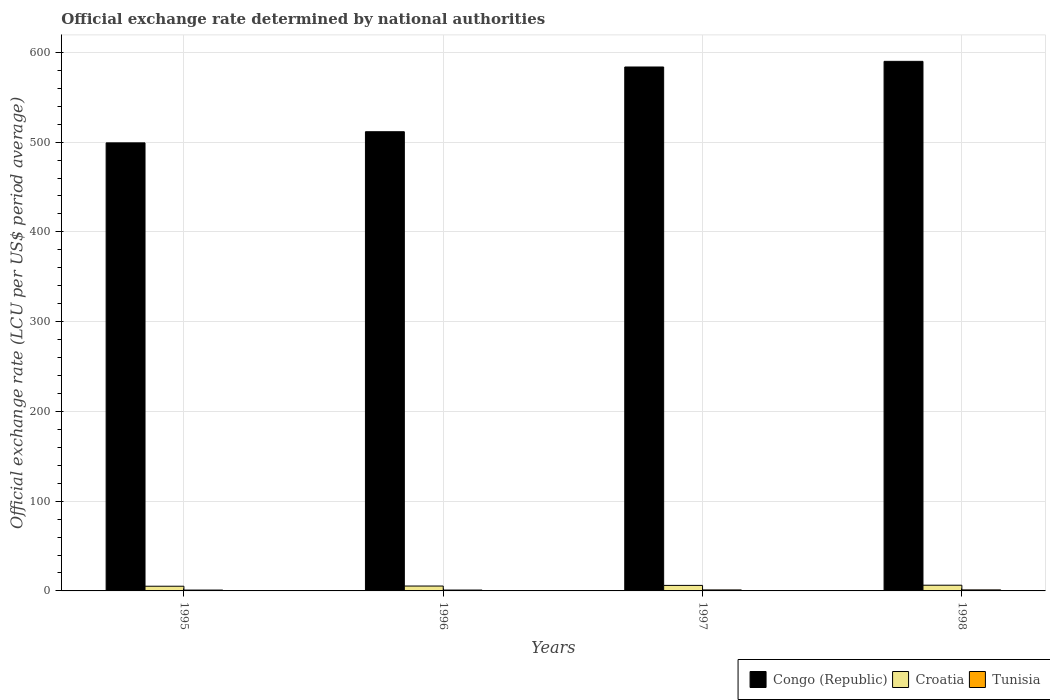How many groups of bars are there?
Provide a succinct answer. 4. Are the number of bars on each tick of the X-axis equal?
Offer a very short reply. Yes. How many bars are there on the 2nd tick from the left?
Make the answer very short. 3. What is the label of the 2nd group of bars from the left?
Provide a short and direct response. 1996. What is the official exchange rate in Croatia in 1997?
Give a very brief answer. 6.16. Across all years, what is the maximum official exchange rate in Croatia?
Give a very brief answer. 6.36. Across all years, what is the minimum official exchange rate in Tunisia?
Offer a very short reply. 0.95. In which year was the official exchange rate in Croatia maximum?
Your answer should be very brief. 1998. In which year was the official exchange rate in Croatia minimum?
Your answer should be very brief. 1995. What is the total official exchange rate in Croatia in the graph?
Give a very brief answer. 23.19. What is the difference between the official exchange rate in Congo (Republic) in 1997 and that in 1998?
Provide a short and direct response. -6.28. What is the difference between the official exchange rate in Croatia in 1998 and the official exchange rate in Tunisia in 1996?
Ensure brevity in your answer.  5.39. What is the average official exchange rate in Congo (Republic) per year?
Provide a short and direct response. 546.08. In the year 1996, what is the difference between the official exchange rate in Croatia and official exchange rate in Tunisia?
Provide a succinct answer. 4.46. In how many years, is the official exchange rate in Croatia greater than 40 LCU?
Keep it short and to the point. 0. What is the ratio of the official exchange rate in Tunisia in 1995 to that in 1996?
Offer a terse response. 0.97. Is the difference between the official exchange rate in Croatia in 1997 and 1998 greater than the difference between the official exchange rate in Tunisia in 1997 and 1998?
Make the answer very short. No. What is the difference between the highest and the second highest official exchange rate in Congo (Republic)?
Offer a terse response. 6.28. What is the difference between the highest and the lowest official exchange rate in Congo (Republic)?
Offer a very short reply. 90.8. What does the 1st bar from the left in 1997 represents?
Keep it short and to the point. Congo (Republic). What does the 1st bar from the right in 1997 represents?
Offer a very short reply. Tunisia. How many bars are there?
Your response must be concise. 12. Are all the bars in the graph horizontal?
Your answer should be very brief. No. What is the difference between two consecutive major ticks on the Y-axis?
Give a very brief answer. 100. Does the graph contain grids?
Ensure brevity in your answer.  Yes. Where does the legend appear in the graph?
Keep it short and to the point. Bottom right. How are the legend labels stacked?
Offer a very short reply. Horizontal. What is the title of the graph?
Your answer should be very brief. Official exchange rate determined by national authorities. What is the label or title of the X-axis?
Give a very brief answer. Years. What is the label or title of the Y-axis?
Keep it short and to the point. Official exchange rate (LCU per US$ period average). What is the Official exchange rate (LCU per US$ period average) of Congo (Republic) in 1995?
Keep it short and to the point. 499.15. What is the Official exchange rate (LCU per US$ period average) of Croatia in 1995?
Offer a very short reply. 5.23. What is the Official exchange rate (LCU per US$ period average) in Tunisia in 1995?
Your answer should be very brief. 0.95. What is the Official exchange rate (LCU per US$ period average) of Congo (Republic) in 1996?
Your response must be concise. 511.55. What is the Official exchange rate (LCU per US$ period average) in Croatia in 1996?
Your answer should be very brief. 5.43. What is the Official exchange rate (LCU per US$ period average) in Tunisia in 1996?
Your answer should be compact. 0.97. What is the Official exchange rate (LCU per US$ period average) of Congo (Republic) in 1997?
Provide a short and direct response. 583.67. What is the Official exchange rate (LCU per US$ period average) of Croatia in 1997?
Provide a short and direct response. 6.16. What is the Official exchange rate (LCU per US$ period average) in Tunisia in 1997?
Ensure brevity in your answer.  1.11. What is the Official exchange rate (LCU per US$ period average) in Congo (Republic) in 1998?
Ensure brevity in your answer.  589.95. What is the Official exchange rate (LCU per US$ period average) in Croatia in 1998?
Give a very brief answer. 6.36. What is the Official exchange rate (LCU per US$ period average) of Tunisia in 1998?
Your response must be concise. 1.14. Across all years, what is the maximum Official exchange rate (LCU per US$ period average) in Congo (Republic)?
Offer a terse response. 589.95. Across all years, what is the maximum Official exchange rate (LCU per US$ period average) of Croatia?
Your answer should be very brief. 6.36. Across all years, what is the maximum Official exchange rate (LCU per US$ period average) of Tunisia?
Make the answer very short. 1.14. Across all years, what is the minimum Official exchange rate (LCU per US$ period average) of Congo (Republic)?
Make the answer very short. 499.15. Across all years, what is the minimum Official exchange rate (LCU per US$ period average) of Croatia?
Provide a succinct answer. 5.23. Across all years, what is the minimum Official exchange rate (LCU per US$ period average) in Tunisia?
Ensure brevity in your answer.  0.95. What is the total Official exchange rate (LCU per US$ period average) in Congo (Republic) in the graph?
Offer a terse response. 2184.32. What is the total Official exchange rate (LCU per US$ period average) in Croatia in the graph?
Give a very brief answer. 23.19. What is the total Official exchange rate (LCU per US$ period average) in Tunisia in the graph?
Your response must be concise. 4.16. What is the difference between the Official exchange rate (LCU per US$ period average) in Congo (Republic) in 1995 and that in 1996?
Your response must be concise. -12.4. What is the difference between the Official exchange rate (LCU per US$ period average) in Croatia in 1995 and that in 1996?
Keep it short and to the point. -0.2. What is the difference between the Official exchange rate (LCU per US$ period average) of Tunisia in 1995 and that in 1996?
Your answer should be very brief. -0.03. What is the difference between the Official exchange rate (LCU per US$ period average) in Congo (Republic) in 1995 and that in 1997?
Your answer should be very brief. -84.52. What is the difference between the Official exchange rate (LCU per US$ period average) in Croatia in 1995 and that in 1997?
Your response must be concise. -0.93. What is the difference between the Official exchange rate (LCU per US$ period average) of Tunisia in 1995 and that in 1997?
Offer a terse response. -0.16. What is the difference between the Official exchange rate (LCU per US$ period average) of Congo (Republic) in 1995 and that in 1998?
Ensure brevity in your answer.  -90.8. What is the difference between the Official exchange rate (LCU per US$ period average) of Croatia in 1995 and that in 1998?
Keep it short and to the point. -1.13. What is the difference between the Official exchange rate (LCU per US$ period average) in Tunisia in 1995 and that in 1998?
Ensure brevity in your answer.  -0.19. What is the difference between the Official exchange rate (LCU per US$ period average) of Congo (Republic) in 1996 and that in 1997?
Offer a very short reply. -72.12. What is the difference between the Official exchange rate (LCU per US$ period average) in Croatia in 1996 and that in 1997?
Provide a succinct answer. -0.73. What is the difference between the Official exchange rate (LCU per US$ period average) of Tunisia in 1996 and that in 1997?
Your answer should be very brief. -0.13. What is the difference between the Official exchange rate (LCU per US$ period average) of Congo (Republic) in 1996 and that in 1998?
Ensure brevity in your answer.  -78.4. What is the difference between the Official exchange rate (LCU per US$ period average) in Croatia in 1996 and that in 1998?
Your answer should be compact. -0.93. What is the difference between the Official exchange rate (LCU per US$ period average) in Tunisia in 1996 and that in 1998?
Offer a very short reply. -0.17. What is the difference between the Official exchange rate (LCU per US$ period average) in Congo (Republic) in 1997 and that in 1998?
Your answer should be compact. -6.28. What is the difference between the Official exchange rate (LCU per US$ period average) of Croatia in 1997 and that in 1998?
Ensure brevity in your answer.  -0.2. What is the difference between the Official exchange rate (LCU per US$ period average) of Tunisia in 1997 and that in 1998?
Offer a terse response. -0.03. What is the difference between the Official exchange rate (LCU per US$ period average) of Congo (Republic) in 1995 and the Official exchange rate (LCU per US$ period average) of Croatia in 1996?
Your answer should be very brief. 493.71. What is the difference between the Official exchange rate (LCU per US$ period average) in Congo (Republic) in 1995 and the Official exchange rate (LCU per US$ period average) in Tunisia in 1996?
Ensure brevity in your answer.  498.18. What is the difference between the Official exchange rate (LCU per US$ period average) in Croatia in 1995 and the Official exchange rate (LCU per US$ period average) in Tunisia in 1996?
Ensure brevity in your answer.  4.26. What is the difference between the Official exchange rate (LCU per US$ period average) in Congo (Republic) in 1995 and the Official exchange rate (LCU per US$ period average) in Croatia in 1997?
Give a very brief answer. 492.99. What is the difference between the Official exchange rate (LCU per US$ period average) of Congo (Republic) in 1995 and the Official exchange rate (LCU per US$ period average) of Tunisia in 1997?
Offer a terse response. 498.04. What is the difference between the Official exchange rate (LCU per US$ period average) in Croatia in 1995 and the Official exchange rate (LCU per US$ period average) in Tunisia in 1997?
Your response must be concise. 4.12. What is the difference between the Official exchange rate (LCU per US$ period average) of Congo (Republic) in 1995 and the Official exchange rate (LCU per US$ period average) of Croatia in 1998?
Your answer should be very brief. 492.79. What is the difference between the Official exchange rate (LCU per US$ period average) in Congo (Republic) in 1995 and the Official exchange rate (LCU per US$ period average) in Tunisia in 1998?
Make the answer very short. 498.01. What is the difference between the Official exchange rate (LCU per US$ period average) of Croatia in 1995 and the Official exchange rate (LCU per US$ period average) of Tunisia in 1998?
Provide a short and direct response. 4.09. What is the difference between the Official exchange rate (LCU per US$ period average) in Congo (Republic) in 1996 and the Official exchange rate (LCU per US$ period average) in Croatia in 1997?
Make the answer very short. 505.39. What is the difference between the Official exchange rate (LCU per US$ period average) of Congo (Republic) in 1996 and the Official exchange rate (LCU per US$ period average) of Tunisia in 1997?
Your answer should be very brief. 510.45. What is the difference between the Official exchange rate (LCU per US$ period average) in Croatia in 1996 and the Official exchange rate (LCU per US$ period average) in Tunisia in 1997?
Your answer should be very brief. 4.33. What is the difference between the Official exchange rate (LCU per US$ period average) of Congo (Republic) in 1996 and the Official exchange rate (LCU per US$ period average) of Croatia in 1998?
Make the answer very short. 505.19. What is the difference between the Official exchange rate (LCU per US$ period average) of Congo (Republic) in 1996 and the Official exchange rate (LCU per US$ period average) of Tunisia in 1998?
Your response must be concise. 510.41. What is the difference between the Official exchange rate (LCU per US$ period average) in Croatia in 1996 and the Official exchange rate (LCU per US$ period average) in Tunisia in 1998?
Ensure brevity in your answer.  4.3. What is the difference between the Official exchange rate (LCU per US$ period average) of Congo (Republic) in 1997 and the Official exchange rate (LCU per US$ period average) of Croatia in 1998?
Offer a very short reply. 577.31. What is the difference between the Official exchange rate (LCU per US$ period average) in Congo (Republic) in 1997 and the Official exchange rate (LCU per US$ period average) in Tunisia in 1998?
Provide a short and direct response. 582.53. What is the difference between the Official exchange rate (LCU per US$ period average) in Croatia in 1997 and the Official exchange rate (LCU per US$ period average) in Tunisia in 1998?
Keep it short and to the point. 5.02. What is the average Official exchange rate (LCU per US$ period average) of Congo (Republic) per year?
Ensure brevity in your answer.  546.08. What is the average Official exchange rate (LCU per US$ period average) of Croatia per year?
Your response must be concise. 5.8. What is the average Official exchange rate (LCU per US$ period average) of Tunisia per year?
Offer a terse response. 1.04. In the year 1995, what is the difference between the Official exchange rate (LCU per US$ period average) in Congo (Republic) and Official exchange rate (LCU per US$ period average) in Croatia?
Offer a terse response. 493.92. In the year 1995, what is the difference between the Official exchange rate (LCU per US$ period average) in Congo (Republic) and Official exchange rate (LCU per US$ period average) in Tunisia?
Ensure brevity in your answer.  498.2. In the year 1995, what is the difference between the Official exchange rate (LCU per US$ period average) of Croatia and Official exchange rate (LCU per US$ period average) of Tunisia?
Give a very brief answer. 4.29. In the year 1996, what is the difference between the Official exchange rate (LCU per US$ period average) in Congo (Republic) and Official exchange rate (LCU per US$ period average) in Croatia?
Provide a succinct answer. 506.12. In the year 1996, what is the difference between the Official exchange rate (LCU per US$ period average) in Congo (Republic) and Official exchange rate (LCU per US$ period average) in Tunisia?
Keep it short and to the point. 510.58. In the year 1996, what is the difference between the Official exchange rate (LCU per US$ period average) in Croatia and Official exchange rate (LCU per US$ period average) in Tunisia?
Provide a short and direct response. 4.46. In the year 1997, what is the difference between the Official exchange rate (LCU per US$ period average) of Congo (Republic) and Official exchange rate (LCU per US$ period average) of Croatia?
Provide a short and direct response. 577.51. In the year 1997, what is the difference between the Official exchange rate (LCU per US$ period average) in Congo (Republic) and Official exchange rate (LCU per US$ period average) in Tunisia?
Give a very brief answer. 582.56. In the year 1997, what is the difference between the Official exchange rate (LCU per US$ period average) in Croatia and Official exchange rate (LCU per US$ period average) in Tunisia?
Keep it short and to the point. 5.05. In the year 1998, what is the difference between the Official exchange rate (LCU per US$ period average) of Congo (Republic) and Official exchange rate (LCU per US$ period average) of Croatia?
Give a very brief answer. 583.59. In the year 1998, what is the difference between the Official exchange rate (LCU per US$ period average) in Congo (Republic) and Official exchange rate (LCU per US$ period average) in Tunisia?
Provide a short and direct response. 588.81. In the year 1998, what is the difference between the Official exchange rate (LCU per US$ period average) of Croatia and Official exchange rate (LCU per US$ period average) of Tunisia?
Your answer should be compact. 5.22. What is the ratio of the Official exchange rate (LCU per US$ period average) of Congo (Republic) in 1995 to that in 1996?
Keep it short and to the point. 0.98. What is the ratio of the Official exchange rate (LCU per US$ period average) of Croatia in 1995 to that in 1996?
Your answer should be very brief. 0.96. What is the ratio of the Official exchange rate (LCU per US$ period average) of Tunisia in 1995 to that in 1996?
Provide a succinct answer. 0.97. What is the ratio of the Official exchange rate (LCU per US$ period average) of Congo (Republic) in 1995 to that in 1997?
Your response must be concise. 0.86. What is the ratio of the Official exchange rate (LCU per US$ period average) in Croatia in 1995 to that in 1997?
Offer a terse response. 0.85. What is the ratio of the Official exchange rate (LCU per US$ period average) in Tunisia in 1995 to that in 1997?
Provide a succinct answer. 0.86. What is the ratio of the Official exchange rate (LCU per US$ period average) of Congo (Republic) in 1995 to that in 1998?
Offer a terse response. 0.85. What is the ratio of the Official exchange rate (LCU per US$ period average) of Croatia in 1995 to that in 1998?
Provide a succinct answer. 0.82. What is the ratio of the Official exchange rate (LCU per US$ period average) of Tunisia in 1995 to that in 1998?
Offer a very short reply. 0.83. What is the ratio of the Official exchange rate (LCU per US$ period average) in Congo (Republic) in 1996 to that in 1997?
Ensure brevity in your answer.  0.88. What is the ratio of the Official exchange rate (LCU per US$ period average) in Croatia in 1996 to that in 1997?
Make the answer very short. 0.88. What is the ratio of the Official exchange rate (LCU per US$ period average) in Tunisia in 1996 to that in 1997?
Give a very brief answer. 0.88. What is the ratio of the Official exchange rate (LCU per US$ period average) of Congo (Republic) in 1996 to that in 1998?
Provide a short and direct response. 0.87. What is the ratio of the Official exchange rate (LCU per US$ period average) of Croatia in 1996 to that in 1998?
Your response must be concise. 0.85. What is the ratio of the Official exchange rate (LCU per US$ period average) of Tunisia in 1996 to that in 1998?
Your response must be concise. 0.85. What is the ratio of the Official exchange rate (LCU per US$ period average) of Congo (Republic) in 1997 to that in 1998?
Keep it short and to the point. 0.99. What is the ratio of the Official exchange rate (LCU per US$ period average) in Croatia in 1997 to that in 1998?
Provide a short and direct response. 0.97. What is the ratio of the Official exchange rate (LCU per US$ period average) of Tunisia in 1997 to that in 1998?
Your answer should be very brief. 0.97. What is the difference between the highest and the second highest Official exchange rate (LCU per US$ period average) of Congo (Republic)?
Provide a short and direct response. 6.28. What is the difference between the highest and the second highest Official exchange rate (LCU per US$ period average) in Croatia?
Give a very brief answer. 0.2. What is the difference between the highest and the second highest Official exchange rate (LCU per US$ period average) in Tunisia?
Offer a very short reply. 0.03. What is the difference between the highest and the lowest Official exchange rate (LCU per US$ period average) in Congo (Republic)?
Offer a very short reply. 90.8. What is the difference between the highest and the lowest Official exchange rate (LCU per US$ period average) of Croatia?
Make the answer very short. 1.13. What is the difference between the highest and the lowest Official exchange rate (LCU per US$ period average) in Tunisia?
Your response must be concise. 0.19. 